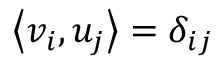<formula> <loc_0><loc_0><loc_500><loc_500>\left \langle v _ { i } , u _ { j } \right \rangle = \delta _ { i j }</formula> 